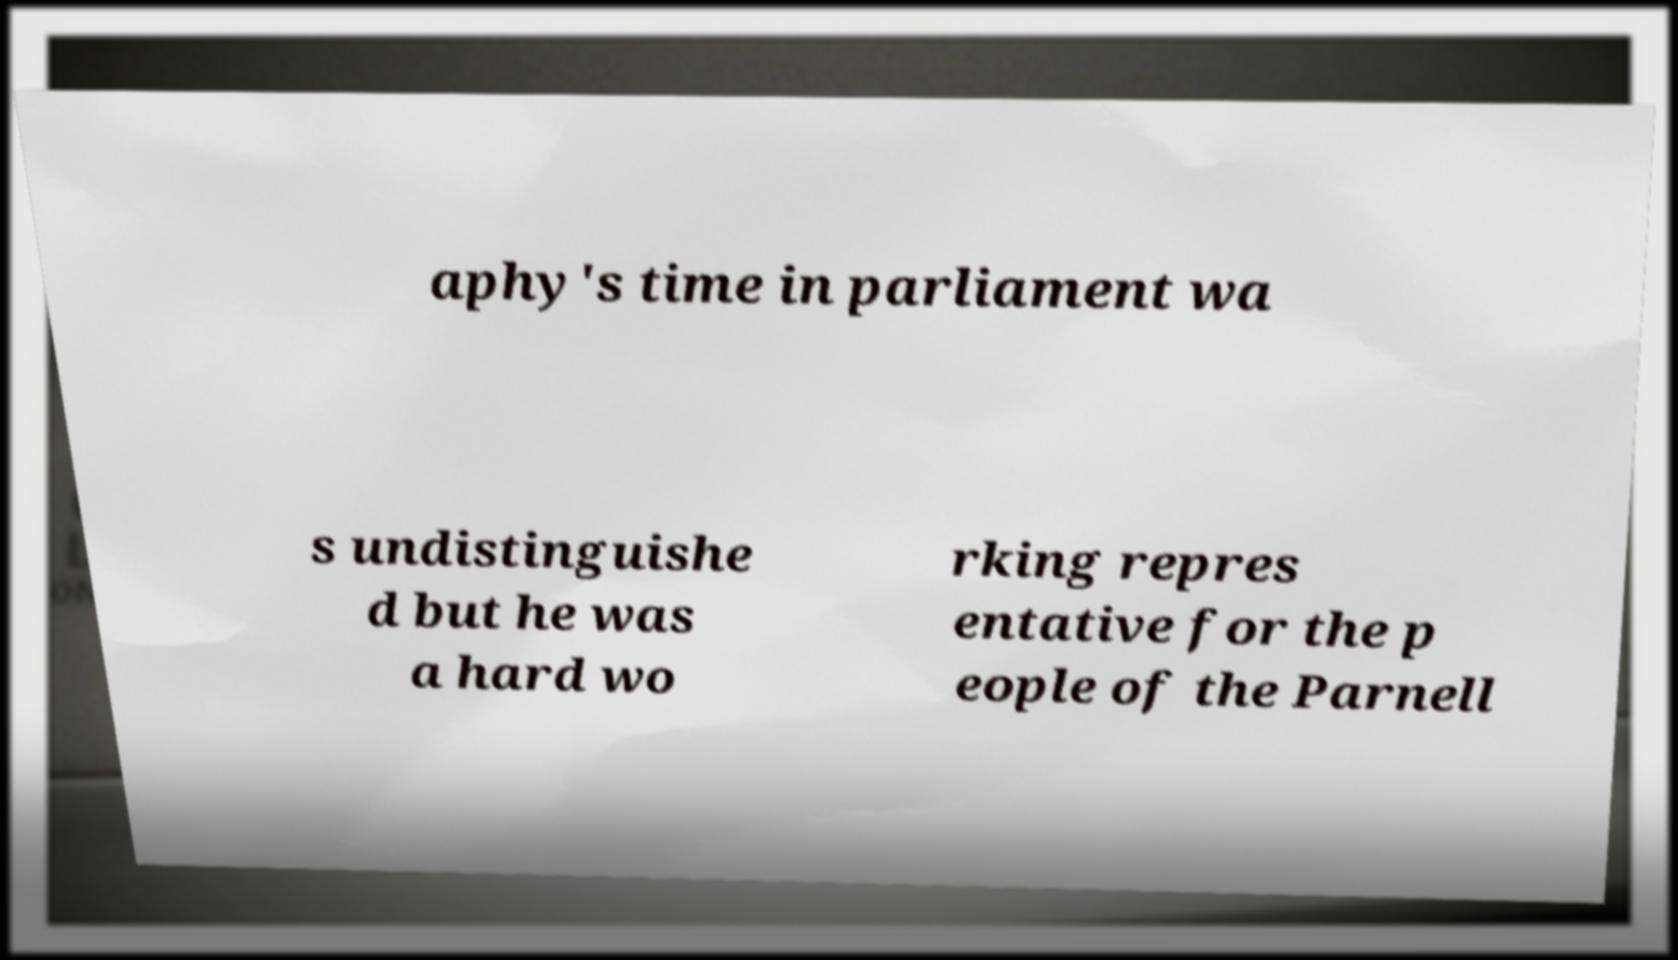Please identify and transcribe the text found in this image. aphy's time in parliament wa s undistinguishe d but he was a hard wo rking repres entative for the p eople of the Parnell 